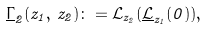<formula> <loc_0><loc_0><loc_500><loc_500>\underline { \Gamma } _ { 2 } ( z _ { 1 } , \, z _ { 2 } ) \colon = \mathcal { L } _ { z _ { 2 } } ( \underline { \mathcal { L } } _ { z _ { 1 } } ( 0 ) ) ,</formula> 